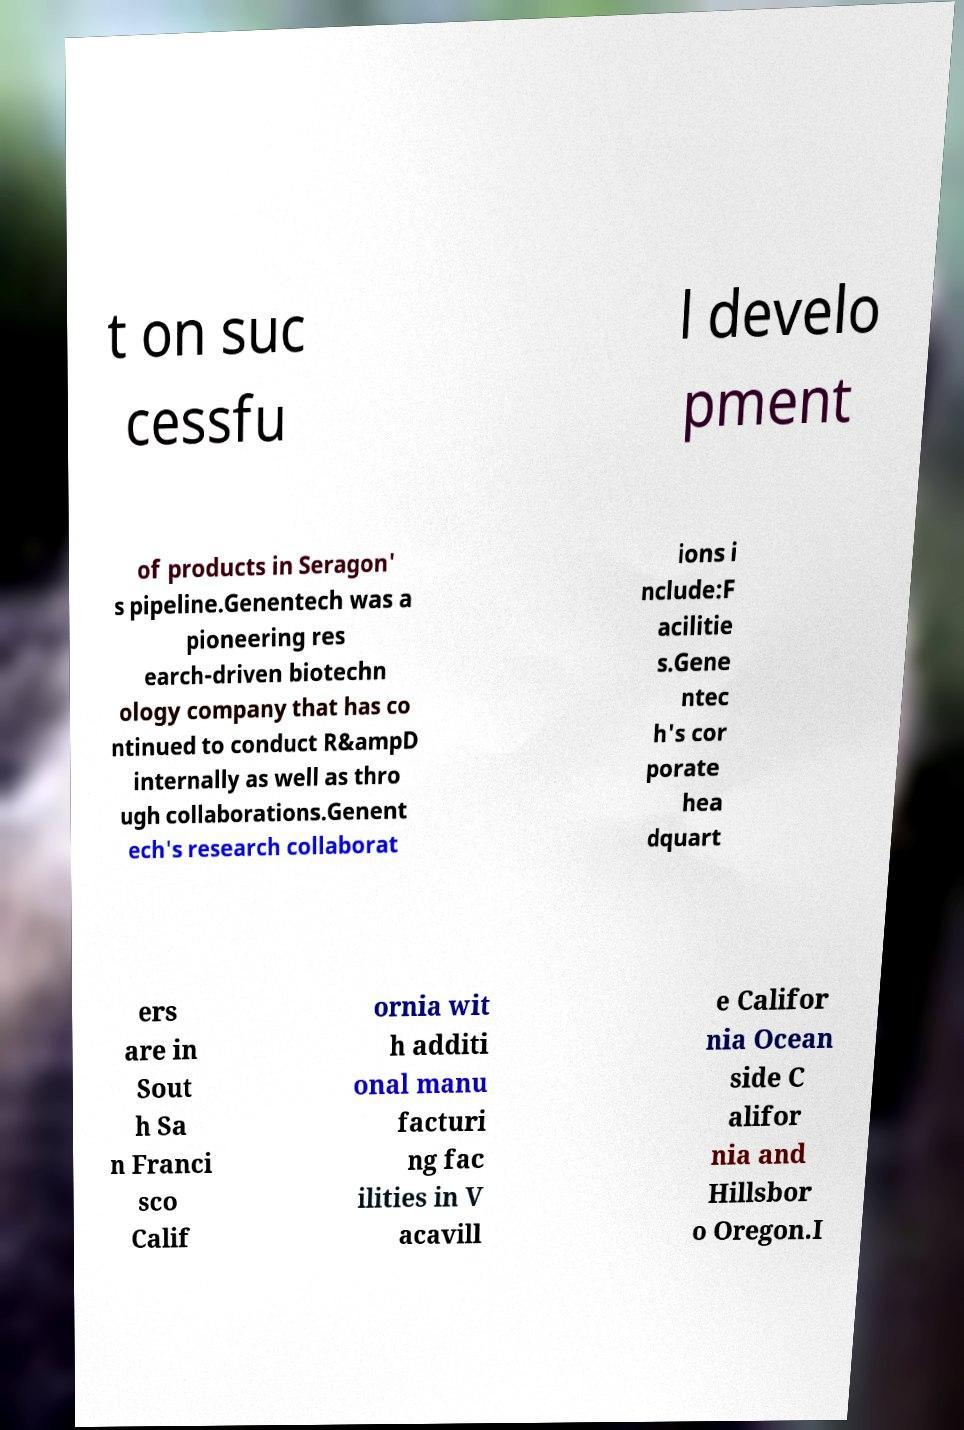Could you extract and type out the text from this image? t on suc cessfu l develo pment of products in Seragon' s pipeline.Genentech was a pioneering res earch-driven biotechn ology company that has co ntinued to conduct R&ampD internally as well as thro ugh collaborations.Genent ech's research collaborat ions i nclude:F acilitie s.Gene ntec h's cor porate hea dquart ers are in Sout h Sa n Franci sco Calif ornia wit h additi onal manu facturi ng fac ilities in V acavill e Califor nia Ocean side C alifor nia and Hillsbor o Oregon.I 